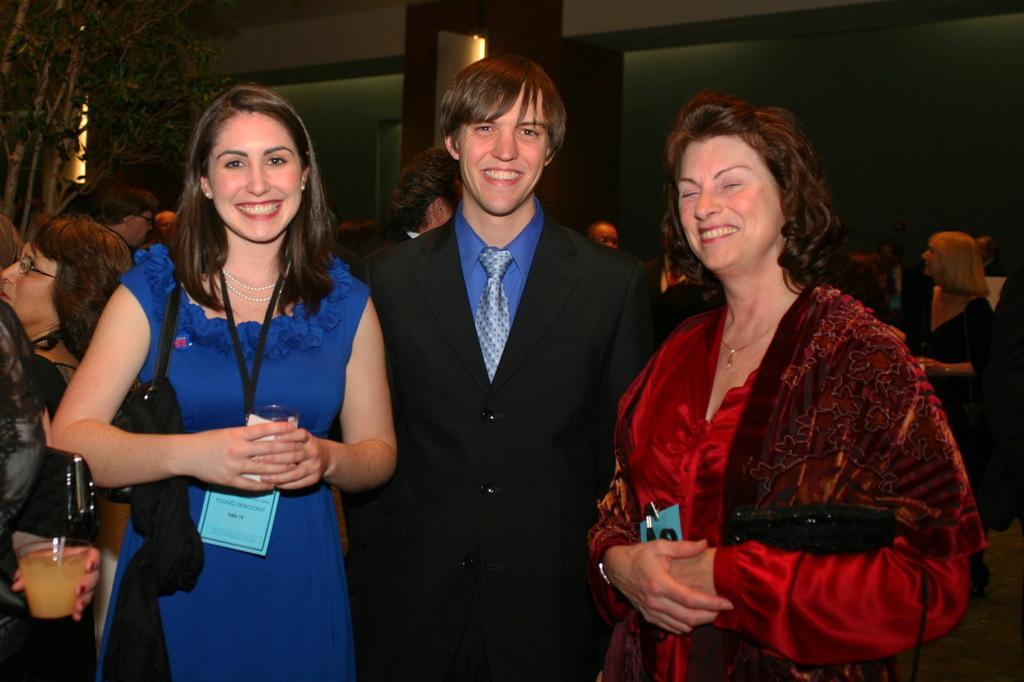Could you give a brief overview of what you see in this image? In this image in front there are three people wearing a smile on their faces. Behind them there are a few other people. In the background of the image there is a wall. On the left side of the image there is a plant. 